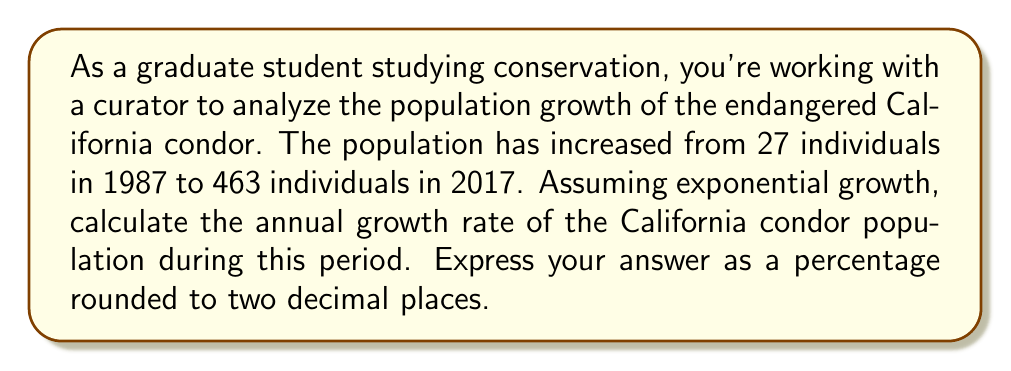Could you help me with this problem? To solve this problem, we'll use the exponential growth formula:

$$A = P(1 + r)^t$$

Where:
$A$ = Final population
$P$ = Initial population
$r$ = Annual growth rate (in decimal form)
$t$ = Time period in years

Given:
$A = 463$ (population in 2017)
$P = 27$ (population in 1987)
$t = 30$ years (2017 - 1987)

Let's solve for $r$:

1) Substitute the known values into the formula:
   $$463 = 27(1 + r)^{30}$$

2) Divide both sides by 27:
   $$\frac{463}{27} = (1 + r)^{30}$$

3) Take the 30th root of both sides:
   $$\sqrt[30]{\frac{463}{27}} = 1 + r$$

4) Subtract 1 from both sides:
   $$\sqrt[30]{\frac{463}{27}} - 1 = r$$

5) Calculate the value:
   $$r \approx 0.0998$$

6) Convert to a percentage by multiplying by 100:
   $$r \approx 9.98\%$$

7) Round to two decimal places:
   $$r \approx 9.98\%$$
Answer: The annual growth rate of the California condor population from 1987 to 2017 was approximately 9.98%. 